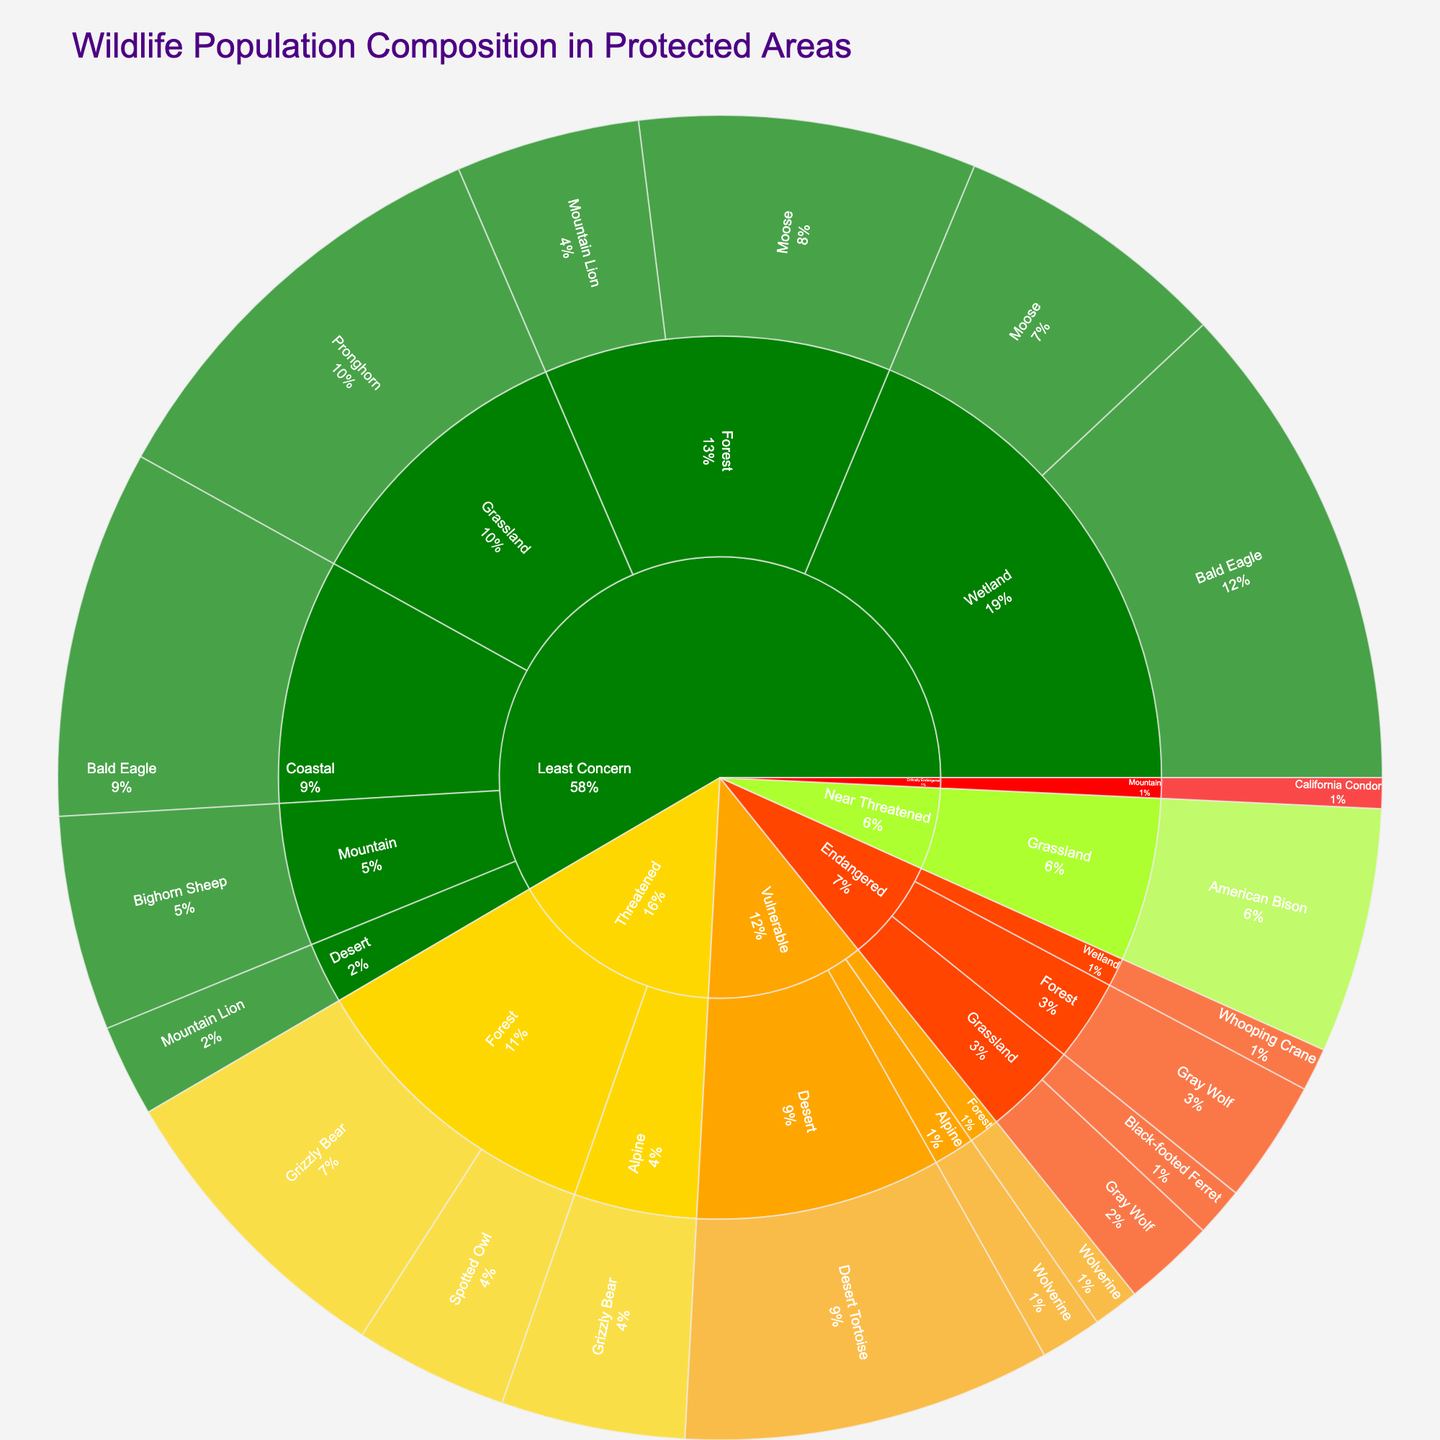What is the title of the sunburst plot? The title appears prominently at the top of the plot, indicating its main subject.
Answer: Wildlife Population Composition in Protected Areas Which species in the "Forest" habitat has the highest population? In the "Forest" habitat section, the populations of different species are shown; the species with the highest number is the one we seek.
Answer: Moose How many species are listed as "Endangered"? Each species' conservation status is labeled, and by counting those labeled as "Endangered," we can determine the number.
Answer: 4 What's the total population of animals in the "Grassland" habitat? The population numbers for all species in the Grassland habitat need to be summed. The species here are Gray Wolf, American Bison, Black-footed Ferret, and Pronghorn. Adding their populations together gives 150+400+80+700.
Answer: 1330 Which habitat has the most species listed as "Least Concern"? By examining all species in each habitat labeled as "Least Concern," we can determine which habitat has the most.
Answer: Forest How does the population of "Bighorn Sheep" compare to "California Condor"? We need to locate both species' populations on the plot and compare the numbers directly.
Answer: Bighorn Sheep has a larger population What is the combined population of species listed as "Vulnerable"? Only the species listed as "Vulnerable" are considered. Their populations are summed: Wolverine (Alpine + Forest) and Desert Tortoise. 100 + 75 + 600.
Answer: 775 Which conservation status has the highest total population? By adding up the populations under each conservation status category, the one with the largest sum can be identified.
Answer: Least Concern What percentage of the total wildlife population does the "Threatened" category represent? First, find the total population by summing all values. Then sum the populations under "Threatened" (Grizzly Bear and Spotted Owl) and calculate the percentage. Total Population = 7855, "Threatened" = 500 + 300 + 250. The percentage is (1050/7855) * 100.
Answer: 13.37% Which species in the "Wetland" habitat is considered "Least Concern"? By reviewing species in the Wetland habitat and cross-referencing with their conservation status, the answer can be found.
Answer: Bald Eagle 